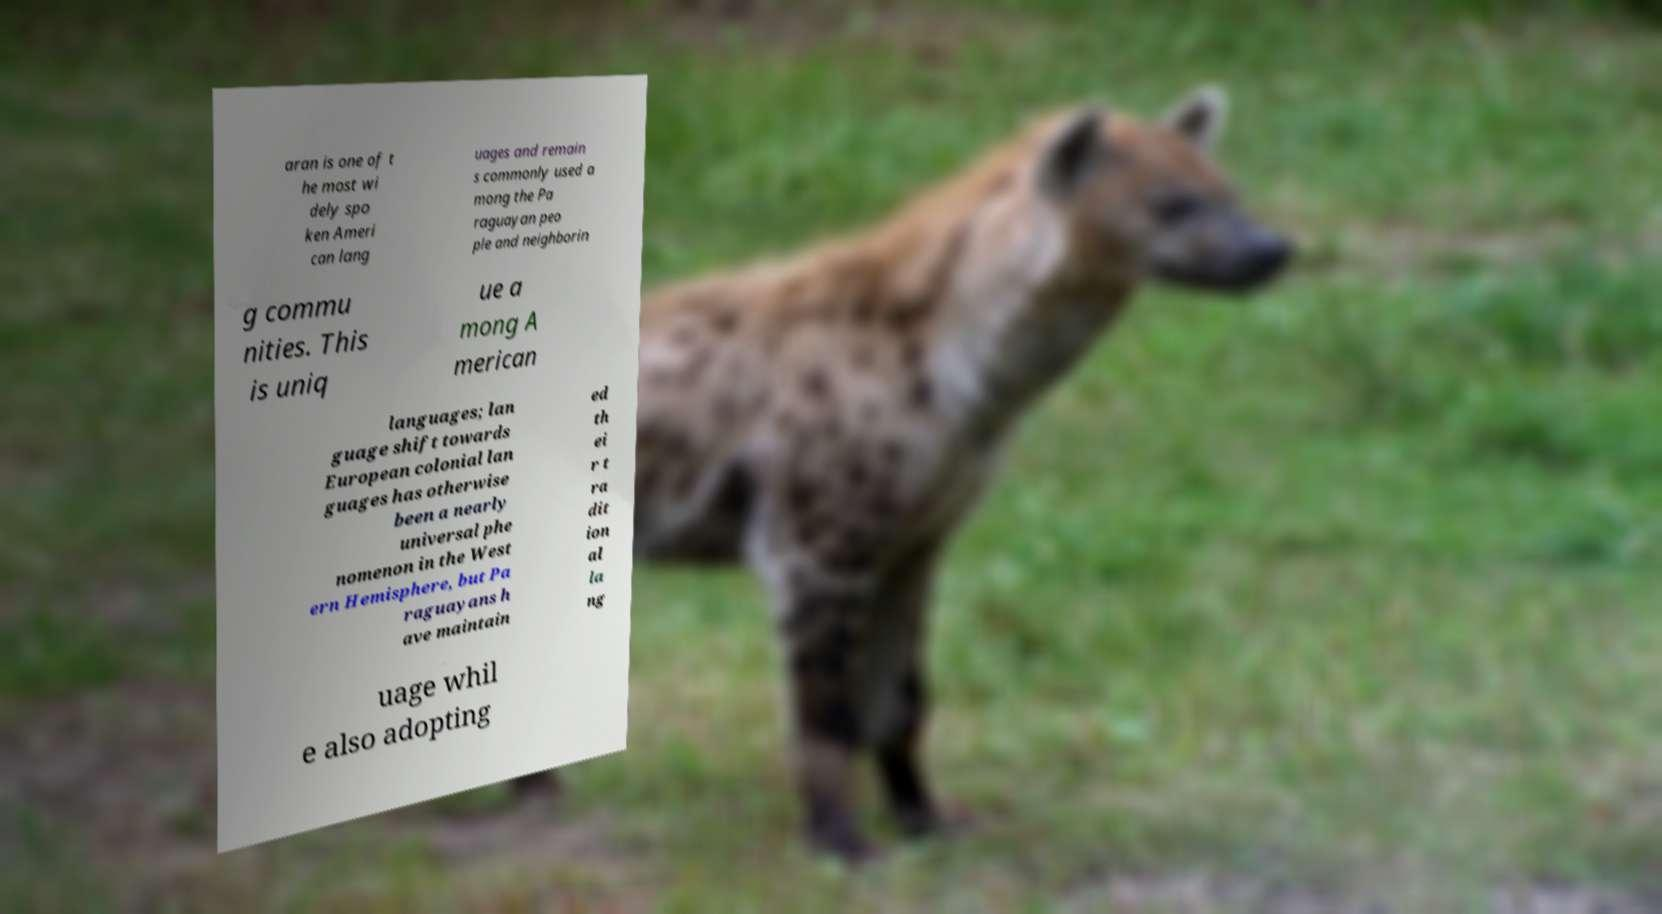Can you read and provide the text displayed in the image?This photo seems to have some interesting text. Can you extract and type it out for me? aran is one of t he most wi dely spo ken Ameri can lang uages and remain s commonly used a mong the Pa raguayan peo ple and neighborin g commu nities. This is uniq ue a mong A merican languages; lan guage shift towards European colonial lan guages has otherwise been a nearly universal phe nomenon in the West ern Hemisphere, but Pa raguayans h ave maintain ed th ei r t ra dit ion al la ng uage whil e also adopting 